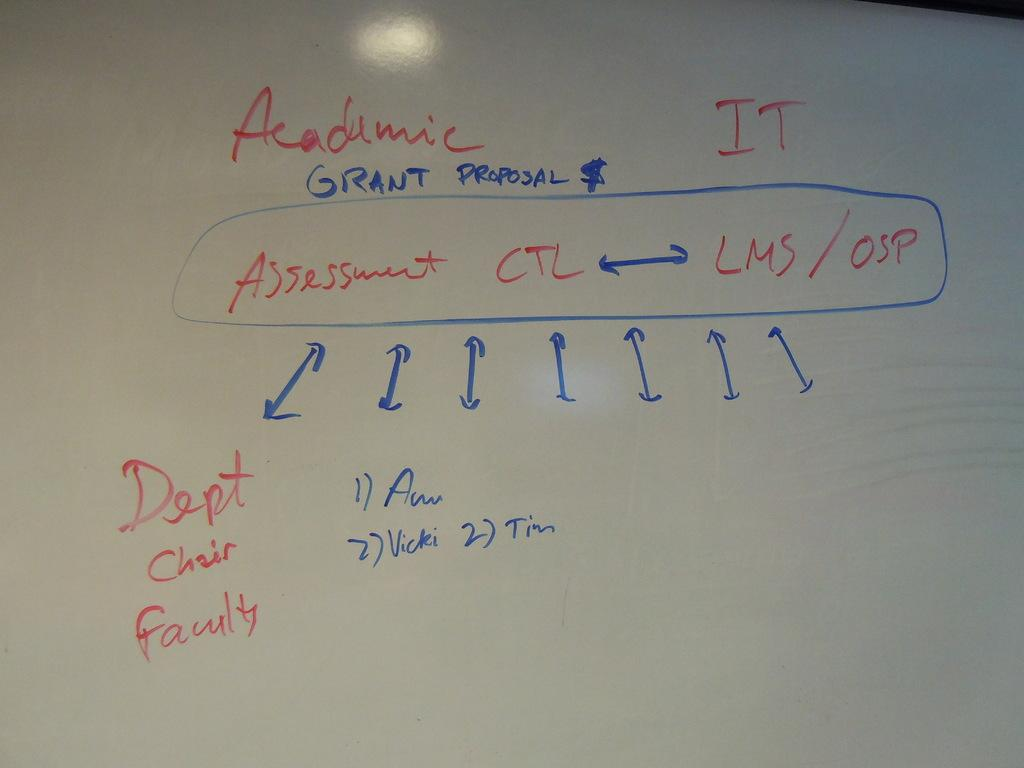<image>
Render a clear and concise summary of the photo. An academic chart displays the flow of grant proposals. 